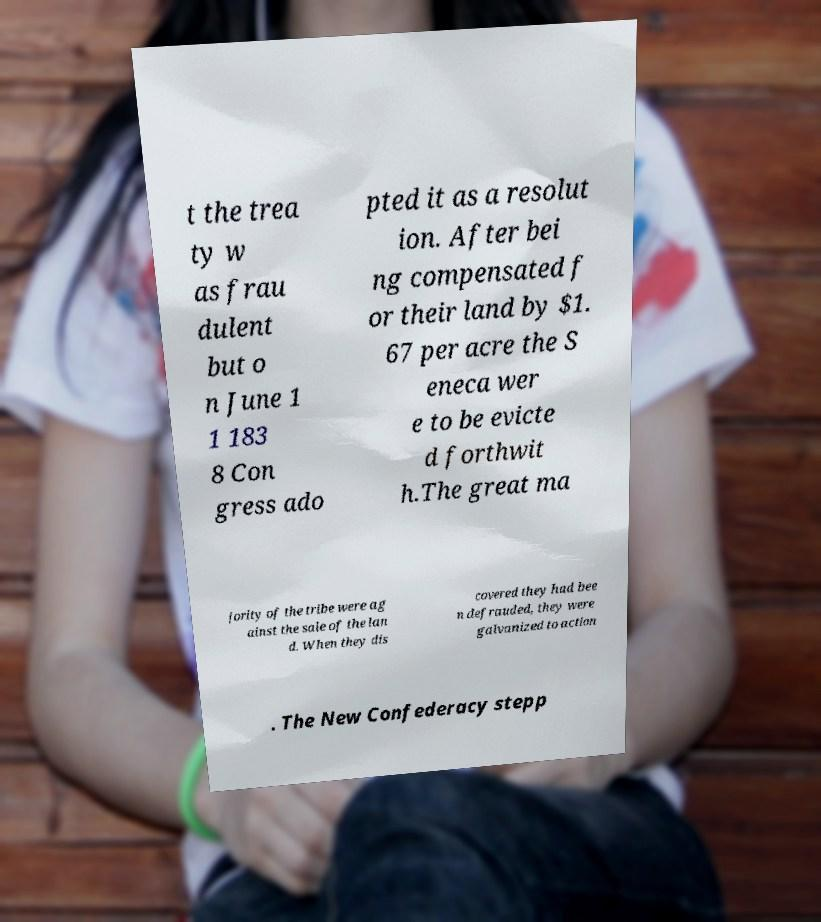Could you assist in decoding the text presented in this image and type it out clearly? t the trea ty w as frau dulent but o n June 1 1 183 8 Con gress ado pted it as a resolut ion. After bei ng compensated f or their land by $1. 67 per acre the S eneca wer e to be evicte d forthwit h.The great ma jority of the tribe were ag ainst the sale of the lan d. When they dis covered they had bee n defrauded, they were galvanized to action . The New Confederacy stepp 